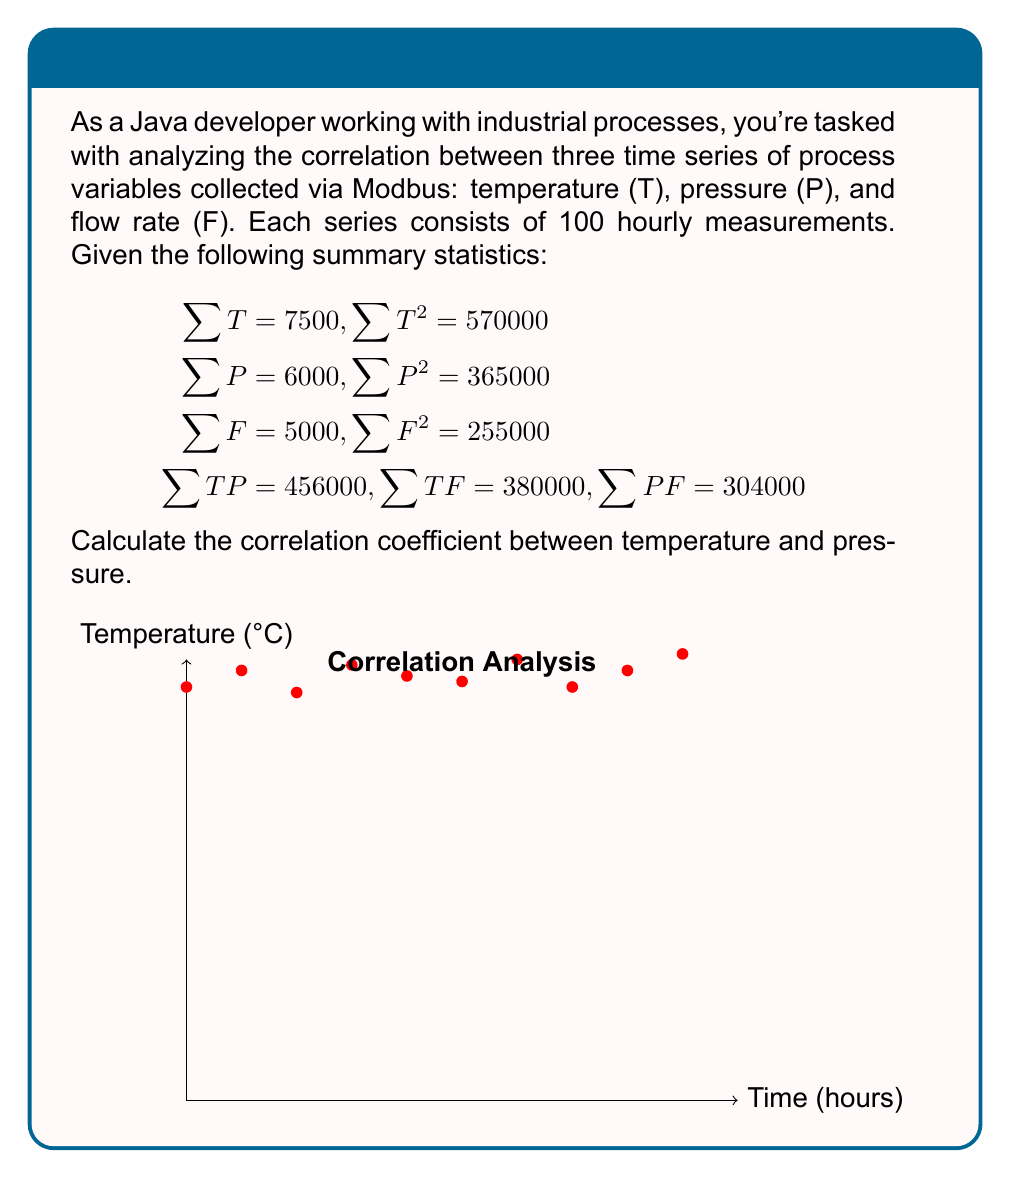Could you help me with this problem? To calculate the correlation coefficient between temperature (T) and pressure (P), we'll use the Pearson correlation coefficient formula:

$$r = \frac{n\sum xy - \sum x \sum y}{\sqrt{[n\sum x^2 - (\sum x)^2][n\sum y^2 - (\sum y)^2]}}$$

Where n is the number of data points (100 in this case), x represents temperature, and y represents pressure.

Step 1: Calculate $\sum xy$ (given as $\sum TP$)
$\sum TP = 456000$

Step 2: Calculate $\sum x$ and $\sum y$ (given as $\sum T$ and $\sum P$)
$\sum T = 7500$
$\sum P = 6000$

Step 3: Calculate $\sum x^2$ and $\sum y^2$ (given as $\sum T^2$ and $\sum P^2$)
$\sum T^2 = 570000$
$\sum P^2 = 365000$

Step 4: Apply the formula
$$\begin{aligned}
r &= \frac{100(456000) - (7500)(6000)}{\sqrt{[100(570000) - (7500)^2][100(365000) - (6000)^2]}} \\
&= \frac{45600000 - 45000000}{\sqrt{(57000000 - 56250000)(36500000 - 36000000)}} \\
&= \frac{600000}{\sqrt{(750000)(500000)}} \\
&= \frac{600000}{\sqrt{375000000000}} \\
&= \frac{600000}{612372.4} \\
&\approx 0.9798
\end{aligned}$$
Answer: $r \approx 0.9798$ 